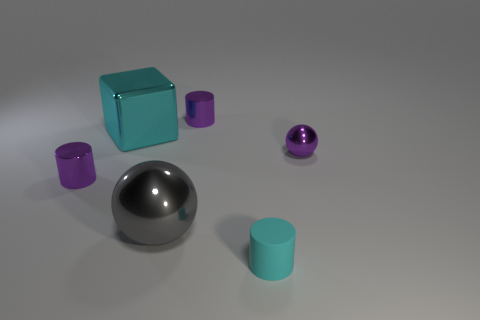Is the number of big spheres greater than the number of metallic objects?
Your answer should be compact. No. The small object that is on the right side of the tiny cyan object has what shape?
Offer a very short reply. Sphere. What number of other metallic things have the same shape as the small cyan thing?
Give a very brief answer. 2. There is a ball that is behind the small cylinder that is to the left of the cyan metal thing; how big is it?
Provide a short and direct response. Small. What number of green objects are large shiny balls or small metal cylinders?
Make the answer very short. 0. Are there fewer blocks to the left of the big cyan object than tiny shiny spheres that are in front of the small cyan rubber cylinder?
Ensure brevity in your answer.  No. There is a cyan shiny object; does it have the same size as the gray shiny ball that is to the right of the big cyan metal thing?
Provide a succinct answer. Yes. How many purple metal cylinders are the same size as the purple sphere?
Ensure brevity in your answer.  2. How many tiny objects are either red metallic things or cubes?
Offer a very short reply. 0. Is there a brown ball?
Give a very brief answer. No. 